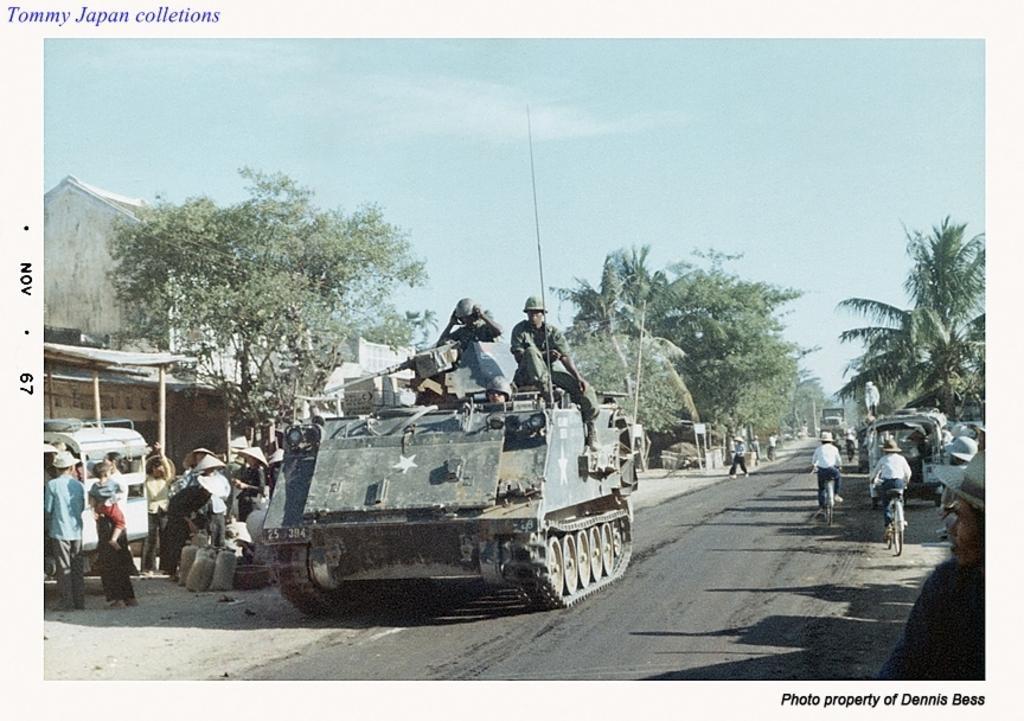In one or two sentences, can you explain what this image depicts? In this image there is a picture. In the picture there is a road. There are vehicles moving on the road. In the foreground there is a Churchill tank on the road. There are people sitting on the Churchill tank. Behind it there are many people standing. There are many bags on the ground. In the background there are buildings and trees. To the right there are people riding bicycles. At the top there is the sky. In the bottom right there is text below the picture. In the top left there is text above the picture. 